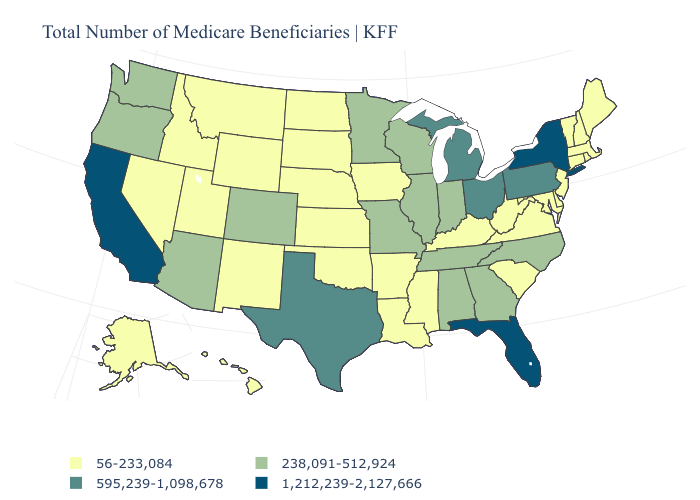Name the states that have a value in the range 56-233,084?
Give a very brief answer. Alaska, Arkansas, Connecticut, Delaware, Hawaii, Idaho, Iowa, Kansas, Kentucky, Louisiana, Maine, Maryland, Massachusetts, Mississippi, Montana, Nebraska, Nevada, New Hampshire, New Jersey, New Mexico, North Dakota, Oklahoma, Rhode Island, South Carolina, South Dakota, Utah, Vermont, Virginia, West Virginia, Wyoming. Does the map have missing data?
Be succinct. No. Does Pennsylvania have the highest value in the USA?
Write a very short answer. No. Does Hawaii have the same value as New Mexico?
Give a very brief answer. Yes. Among the states that border Vermont , does Massachusetts have the lowest value?
Quick response, please. Yes. Name the states that have a value in the range 238,091-512,924?
Answer briefly. Alabama, Arizona, Colorado, Georgia, Illinois, Indiana, Minnesota, Missouri, North Carolina, Oregon, Tennessee, Washington, Wisconsin. Name the states that have a value in the range 595,239-1,098,678?
Quick response, please. Michigan, Ohio, Pennsylvania, Texas. What is the highest value in the USA?
Quick response, please. 1,212,239-2,127,666. Does Arkansas have the highest value in the South?
Be succinct. No. Does New Hampshire have the highest value in the Northeast?
Concise answer only. No. Does Iowa have a lower value than Alabama?
Answer briefly. Yes. What is the value of Vermont?
Be succinct. 56-233,084. What is the value of New Hampshire?
Answer briefly. 56-233,084. Name the states that have a value in the range 595,239-1,098,678?
Quick response, please. Michigan, Ohio, Pennsylvania, Texas. What is the value of Virginia?
Short answer required. 56-233,084. 